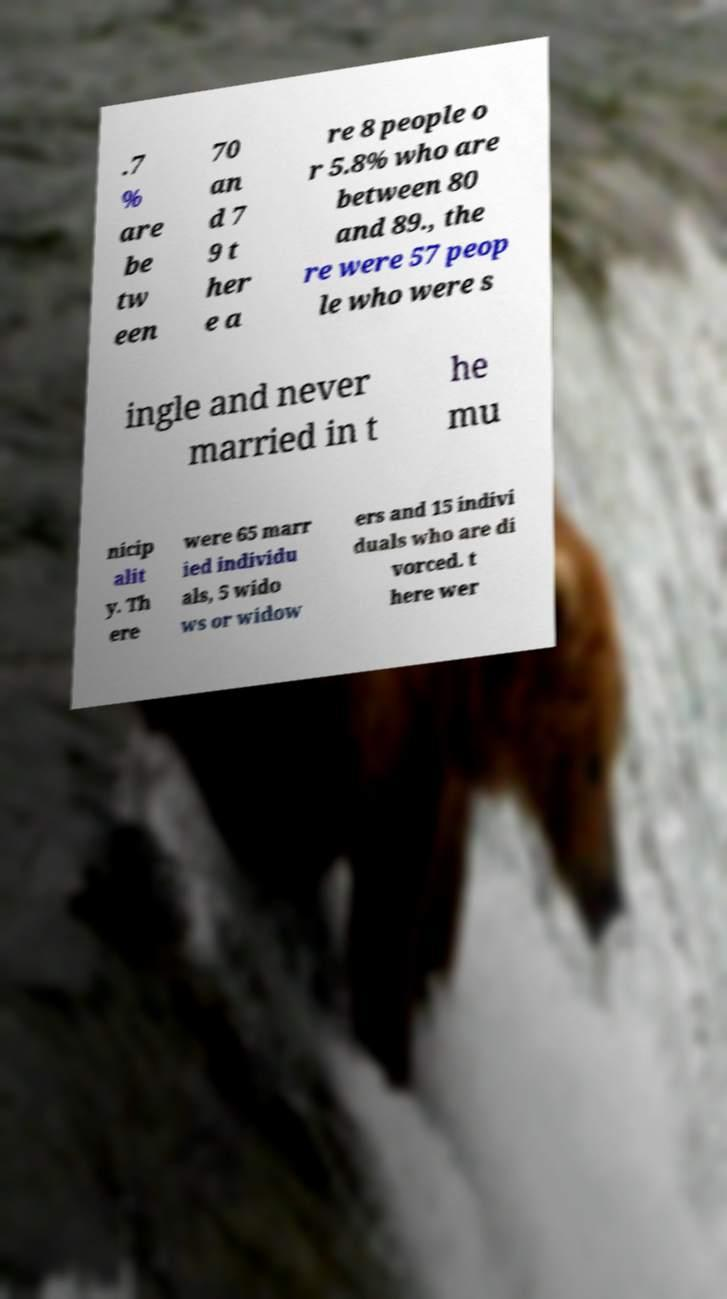Please identify and transcribe the text found in this image. .7 % are be tw een 70 an d 7 9 t her e a re 8 people o r 5.8% who are between 80 and 89., the re were 57 peop le who were s ingle and never married in t he mu nicip alit y. Th ere were 65 marr ied individu als, 5 wido ws or widow ers and 15 indivi duals who are di vorced. t here wer 